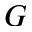<formula> <loc_0><loc_0><loc_500><loc_500>G</formula> 